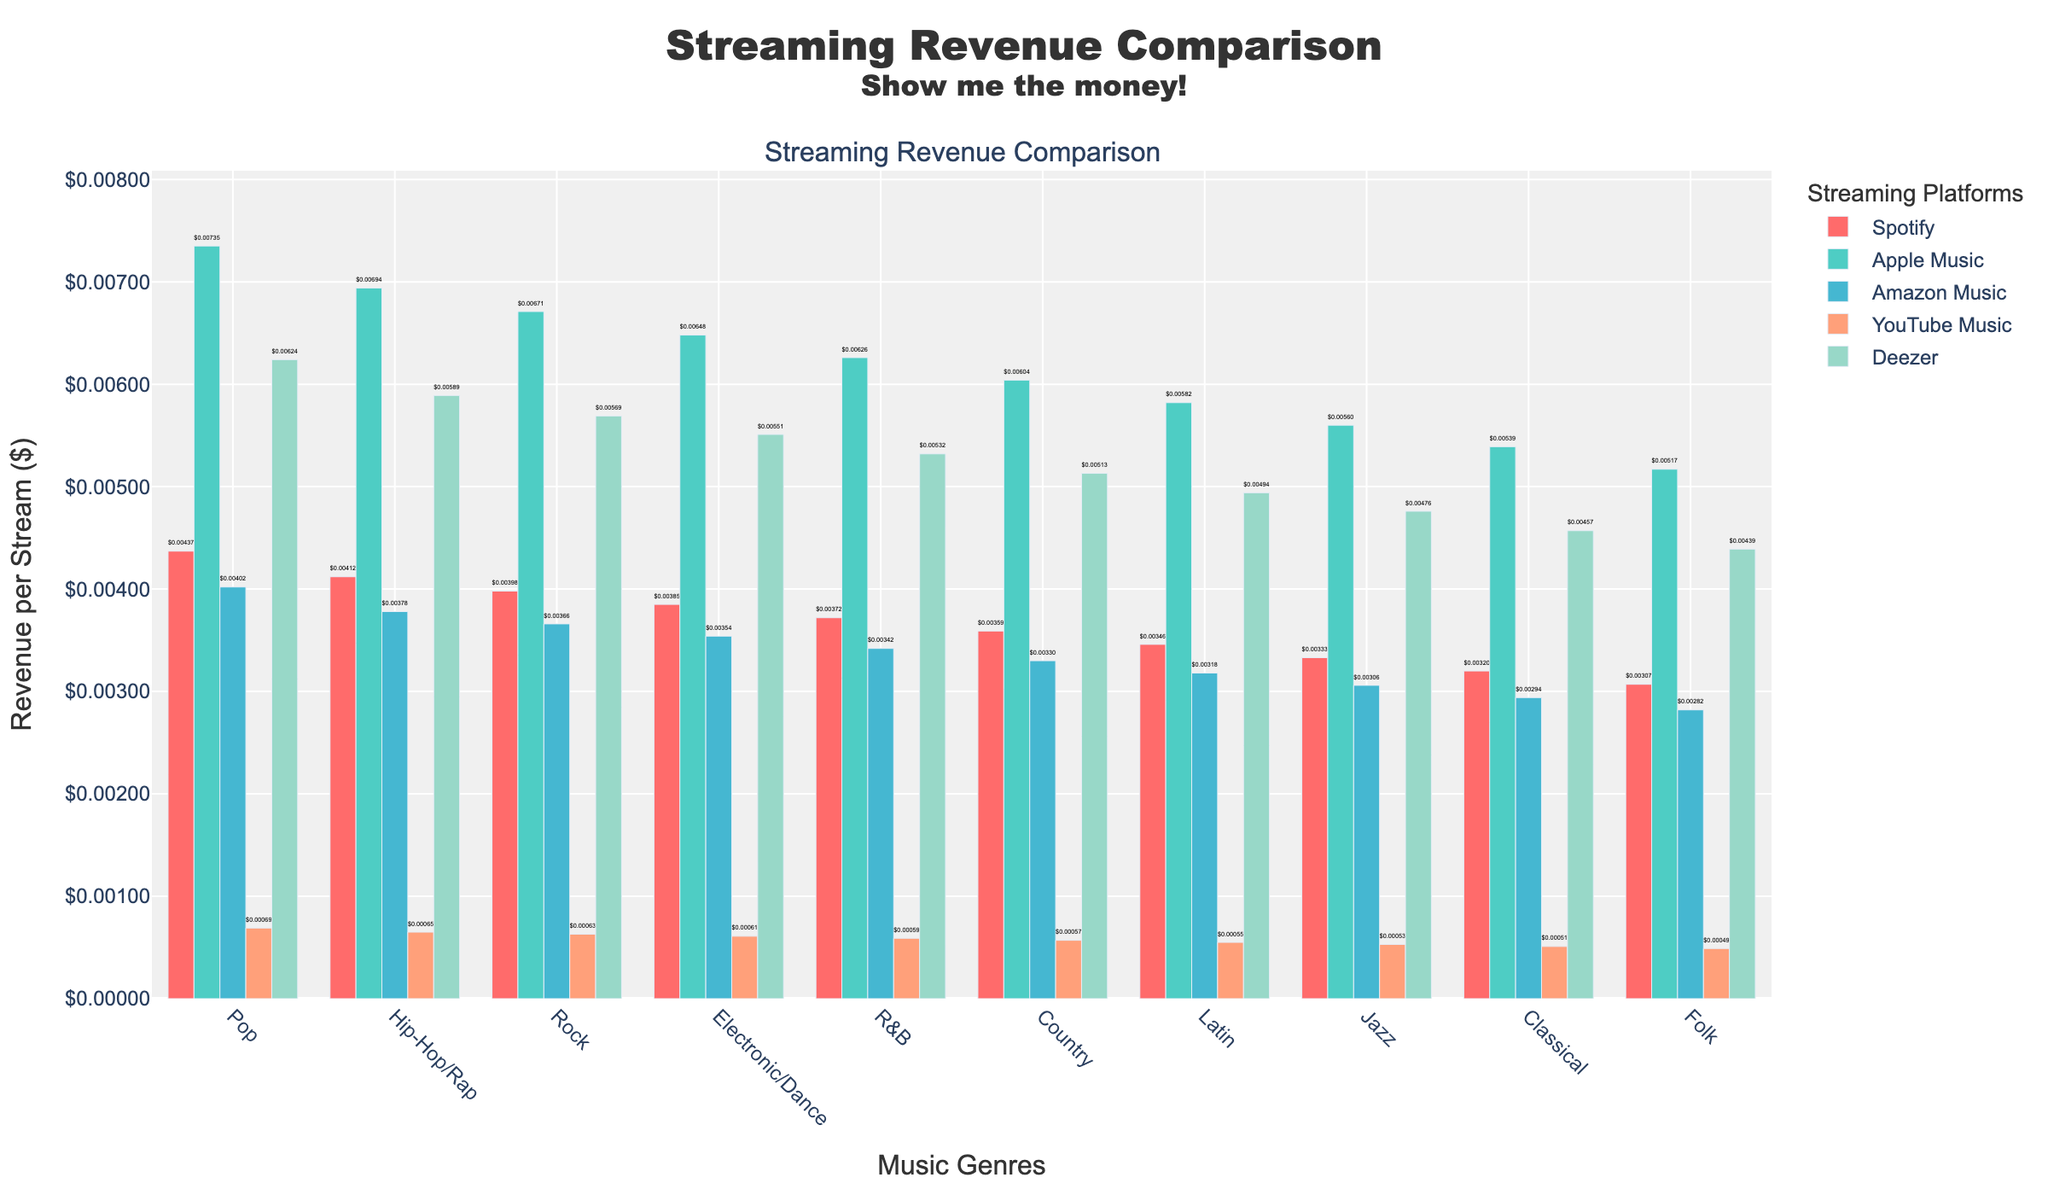Which genre has the highest streaming revenue on Apple Music? Apple Music revenue is highest for the Pop genre, as indicated by the highest bar for Pop in Apple Music's section.
Answer: Pop Which platform shows the lowest streaming revenue for Hip-Hop/Rap? By comparing the heights of the bars for the Hip-Hop/Rap genre across all platforms, YouTube Music has the smallest bar, indicating the lowest revenue.
Answer: YouTube Music How does the revenue of Jazz on Deezer compare to that on Spotify? The bar for Jazz on Deezer is higher than the bar for Jazz on Spotify, indicating that the streaming revenue for Jazz is higher on Deezer compared to Spotify.
Answer: Higher on Deezer What is the difference in revenue per stream between the highest and lowest genres on Apple Music? The highest revenue per stream on Apple Music is for Pop at $0.00735, and the lowest is for Folk at $0.00517. The difference is calculated as $0.00735 - $0.00517.
Answer: $0.00218 What's the average streaming revenue for the Rock genre across all platforms? Add the revenue for Rock on Spotify ($0.00398), Apple Music ($0.00671), Amazon Music ($0.00366), YouTube Music ($0.00063), and Deezer ($0.00569). Then divide by 5: (0.00398 + 0.00671 + 0.00366 + 0.00063 + 0.00569) / 5.
Answer: $0.00453 Which platform consistently shows the lowest revenue across all genres? By visually inspecting the bars for all platforms across every genre, YouTube Music consistently has the lowest bars, indicating the lowest revenue.
Answer: YouTube Music What is the color representation for Apple Music bars? The bars representing Apple Music are colored in a light cerulean shade.
Answer: Light cerulean For which genre do Spotify and Amazon Music have nearly equal streaming revenue? Visual comparison shows that the bars for Electronic/Dance on Spotify ($0.00385) and Amazon Music ($0.00354) are very close in height and value.
Answer: Electronic/Dance Which genre has the least total streaming revenue across Spotify and Apple Music combined? Calculate the sum of revenues for each genre across Spotify and Apple Music. The Classical genre has the lowest combined revenue: ($0.00320 + $0.00539) = $0.00859.
Answer: Classical Which genre on Deezer generates almost double the revenue compared to YouTube Music? The R&B genre on Deezer ($0.00532) generates nearly double the revenue compared to YouTube Music ($0.00059), as the height of the bar on Deezer is about twice that on YouTube Music.
Answer: R&B 